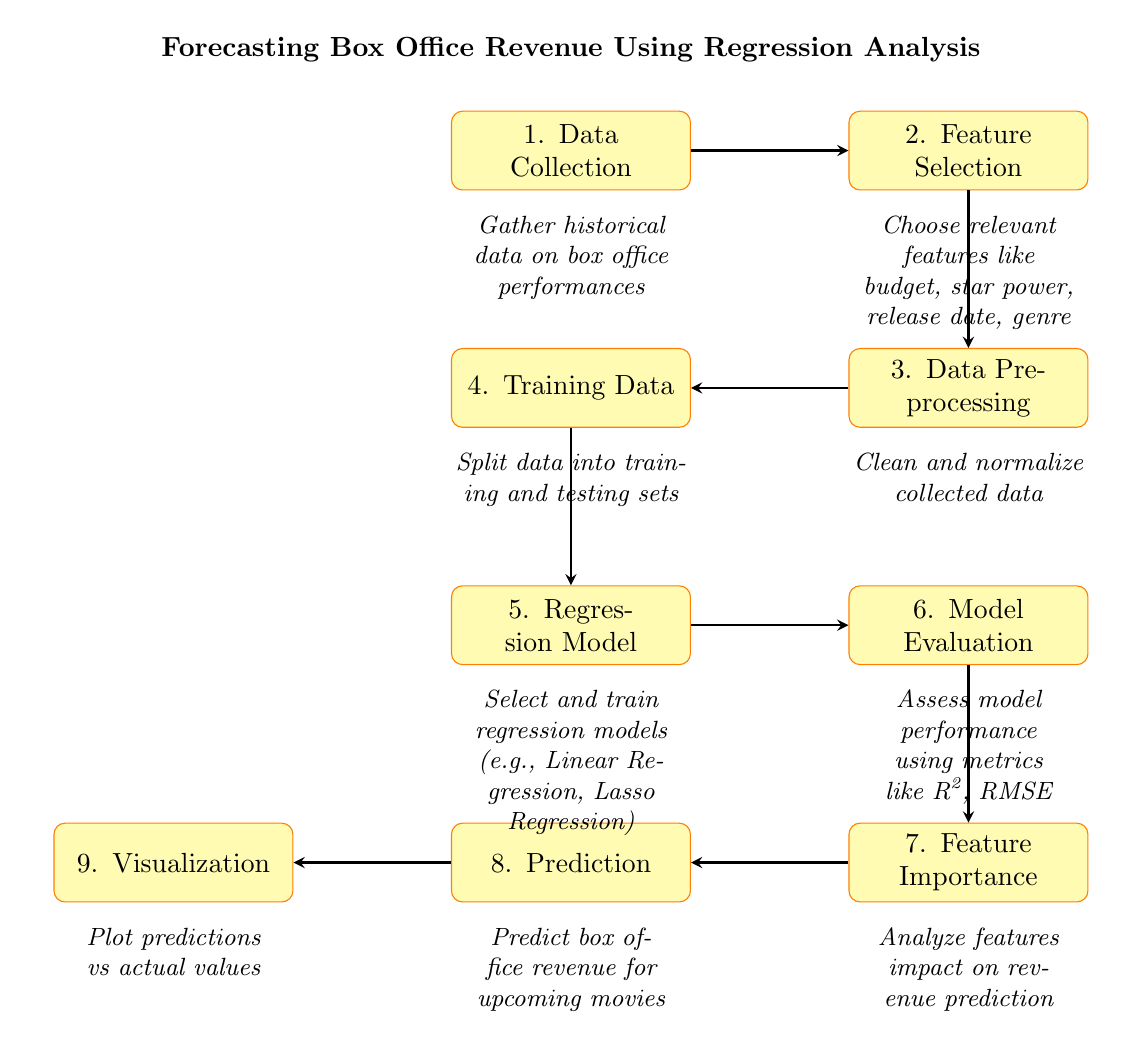What is the first step in the process? The first step in the process, as indicated in the diagram, is "Data Collection". This is the starting point where historical data on box office performances is gathered.
Answer: Data Collection How many steps are in the diagram? The diagram contains a total of nine steps, listed sequentially from "Data Collection" to "Visualization". Each step represents a critical part of the regression analysis process.
Answer: Nine What follows after “Model Evaluation”? After “Model Evaluation”, the next step in the diagram is “Feature Importance”. This indicates the analysis of the feature impacts on the prediction of revenue.
Answer: Feature Importance Which step involves cleaning and normalizing data? The step that involves cleaning and normalizing data is “Data Preprocessing”. This step comes after feature selection and before the training data step.
Answer: Data Preprocessing What kind of model is selected in step five? In step five, a "Regression Model" is selected. This includes methods like Linear Regression or Lasso Regression, which are used for the analysis process.
Answer: Regression Model What metric is suggested for model performance assessment? The suggested metric for model performance assessment is R-squared. This metric helps in evaluating how well the regression model predicts the target variable.
Answer: R-squared How does the model determine which features are most impactful? The model determines which features are most impactful through the “Feature Importance” step, where the effect of each feature on revenue prediction is analyzed.
Answer: Feature Importance What do you visualize in the final step? In the final step, "Visualization", predictions are plotted against actual values. This visually represents the accuracy and effectiveness of the revenue predictions made by the model.
Answer: Plot predictions vs actual values 